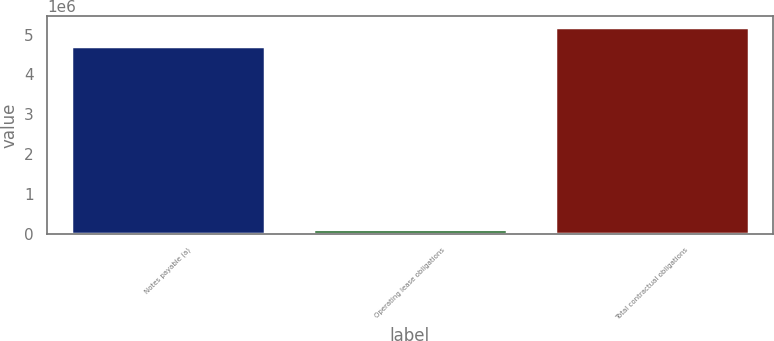Convert chart. <chart><loc_0><loc_0><loc_500><loc_500><bar_chart><fcel>Notes payable (a)<fcel>Operating lease obligations<fcel>Total contractual obligations<nl><fcel>4.72513e+06<fcel>118125<fcel>5.19764e+06<nl></chart> 